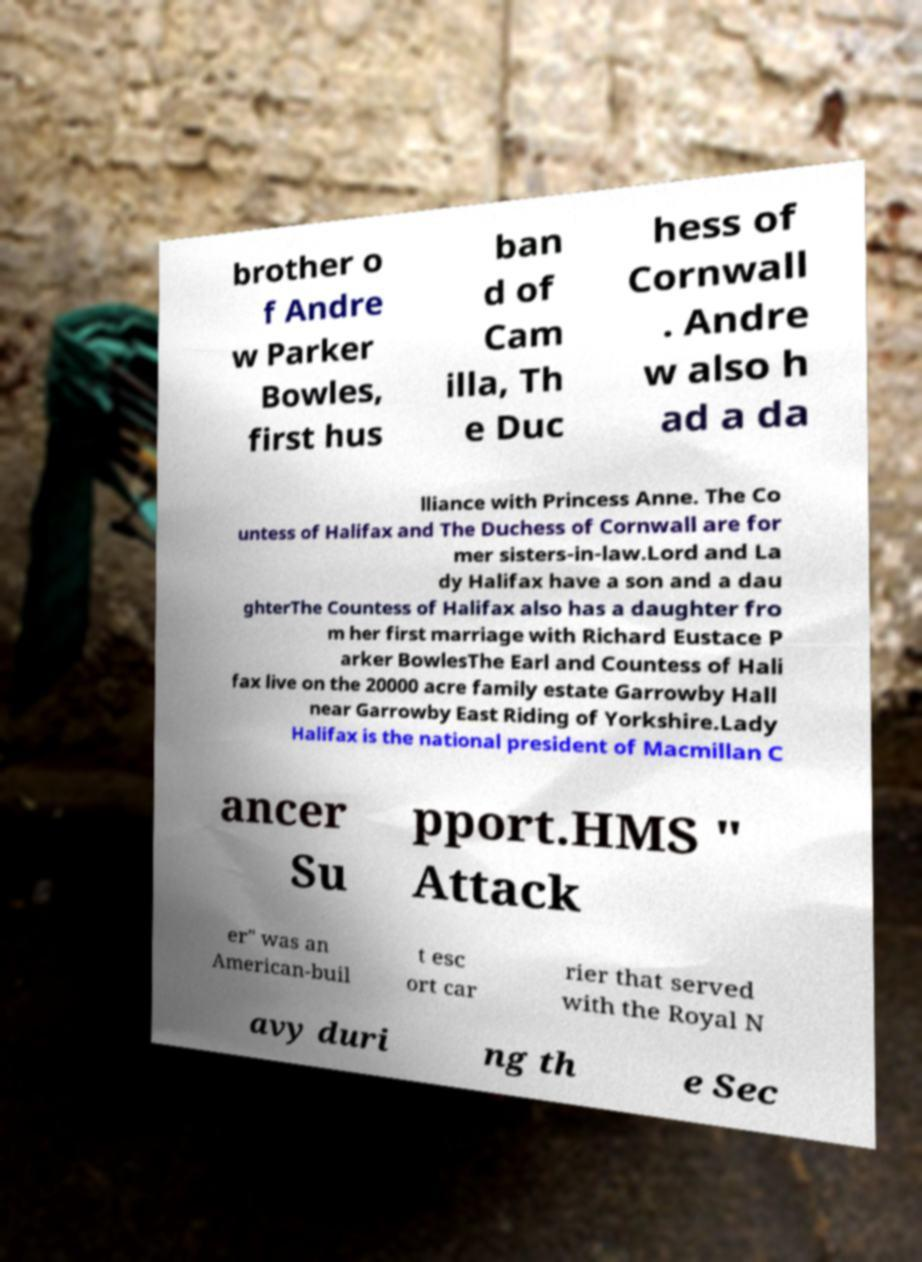I need the written content from this picture converted into text. Can you do that? brother o f Andre w Parker Bowles, first hus ban d of Cam illa, Th e Duc hess of Cornwall . Andre w also h ad a da lliance with Princess Anne. The Co untess of Halifax and The Duchess of Cornwall are for mer sisters-in-law.Lord and La dy Halifax have a son and a dau ghterThe Countess of Halifax also has a daughter fro m her first marriage with Richard Eustace P arker BowlesThe Earl and Countess of Hali fax live on the 20000 acre family estate Garrowby Hall near Garrowby East Riding of Yorkshire.Lady Halifax is the national president of Macmillan C ancer Su pport.HMS " Attack er" was an American-buil t esc ort car rier that served with the Royal N avy duri ng th e Sec 